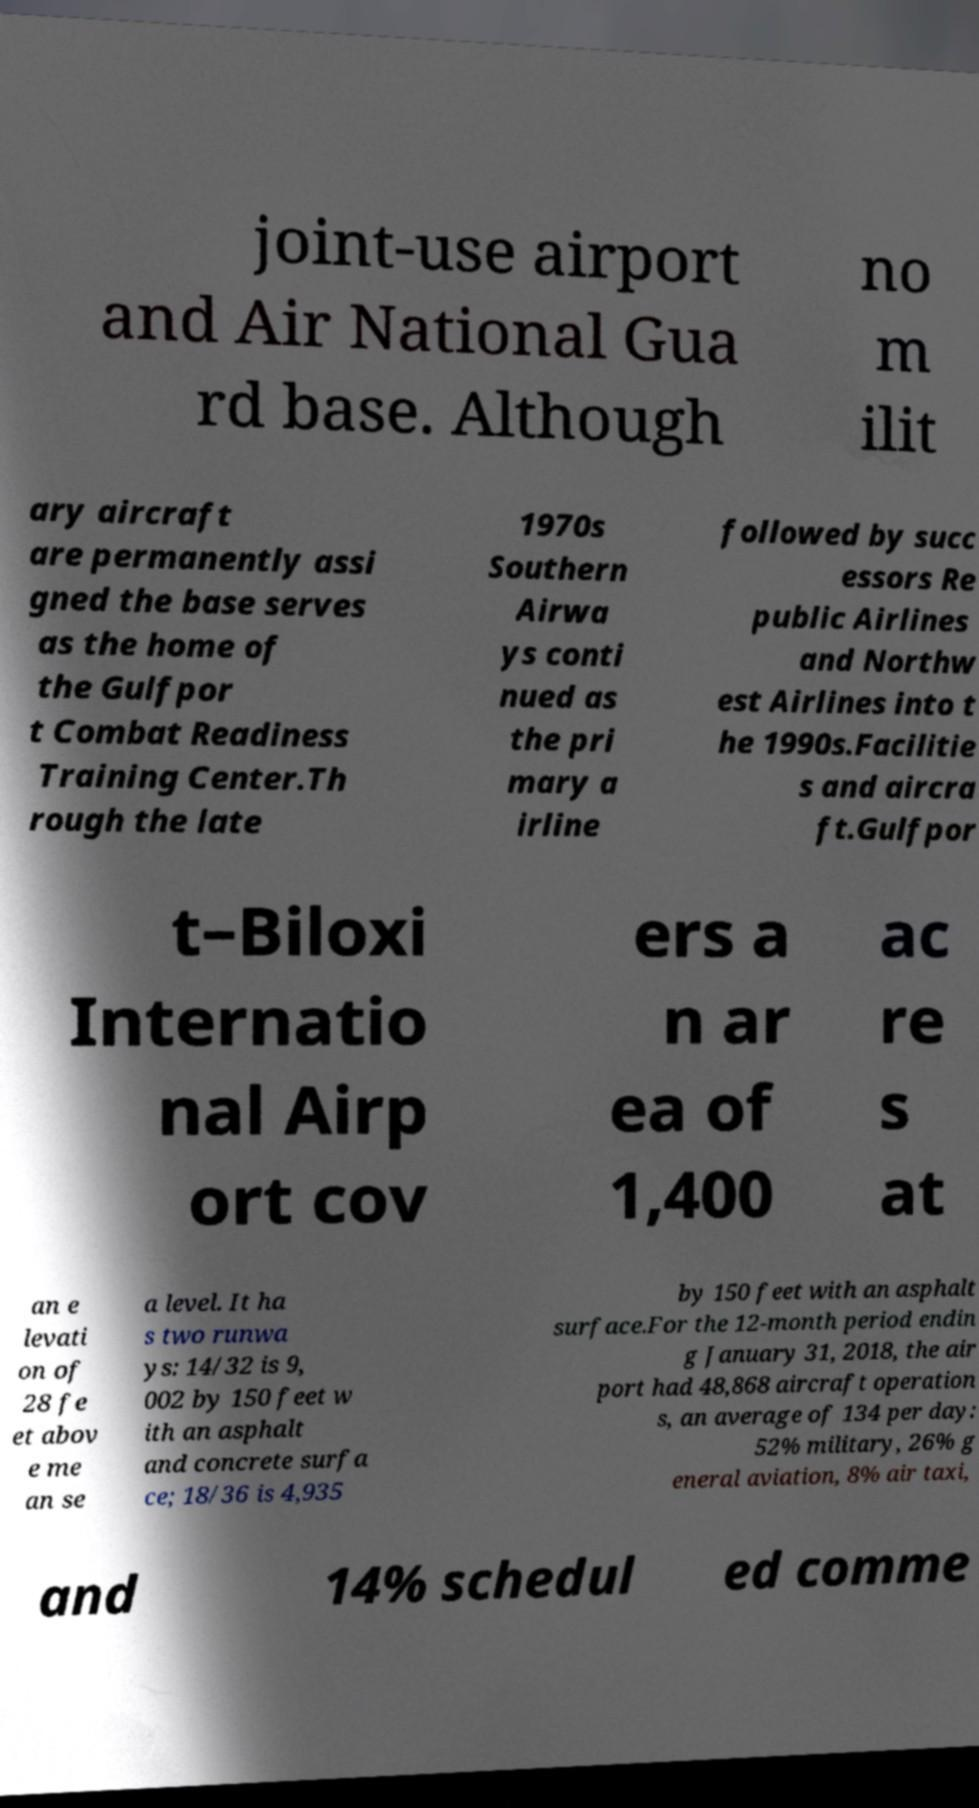What messages or text are displayed in this image? I need them in a readable, typed format. joint-use airport and Air National Gua rd base. Although no m ilit ary aircraft are permanently assi gned the base serves as the home of the Gulfpor t Combat Readiness Training Center.Th rough the late 1970s Southern Airwa ys conti nued as the pri mary a irline followed by succ essors Re public Airlines and Northw est Airlines into t he 1990s.Facilitie s and aircra ft.Gulfpor t–Biloxi Internatio nal Airp ort cov ers a n ar ea of 1,400 ac re s at an e levati on of 28 fe et abov e me an se a level. It ha s two runwa ys: 14/32 is 9, 002 by 150 feet w ith an asphalt and concrete surfa ce; 18/36 is 4,935 by 150 feet with an asphalt surface.For the 12-month period endin g January 31, 2018, the air port had 48,868 aircraft operation s, an average of 134 per day: 52% military, 26% g eneral aviation, 8% air taxi, and 14% schedul ed comme 